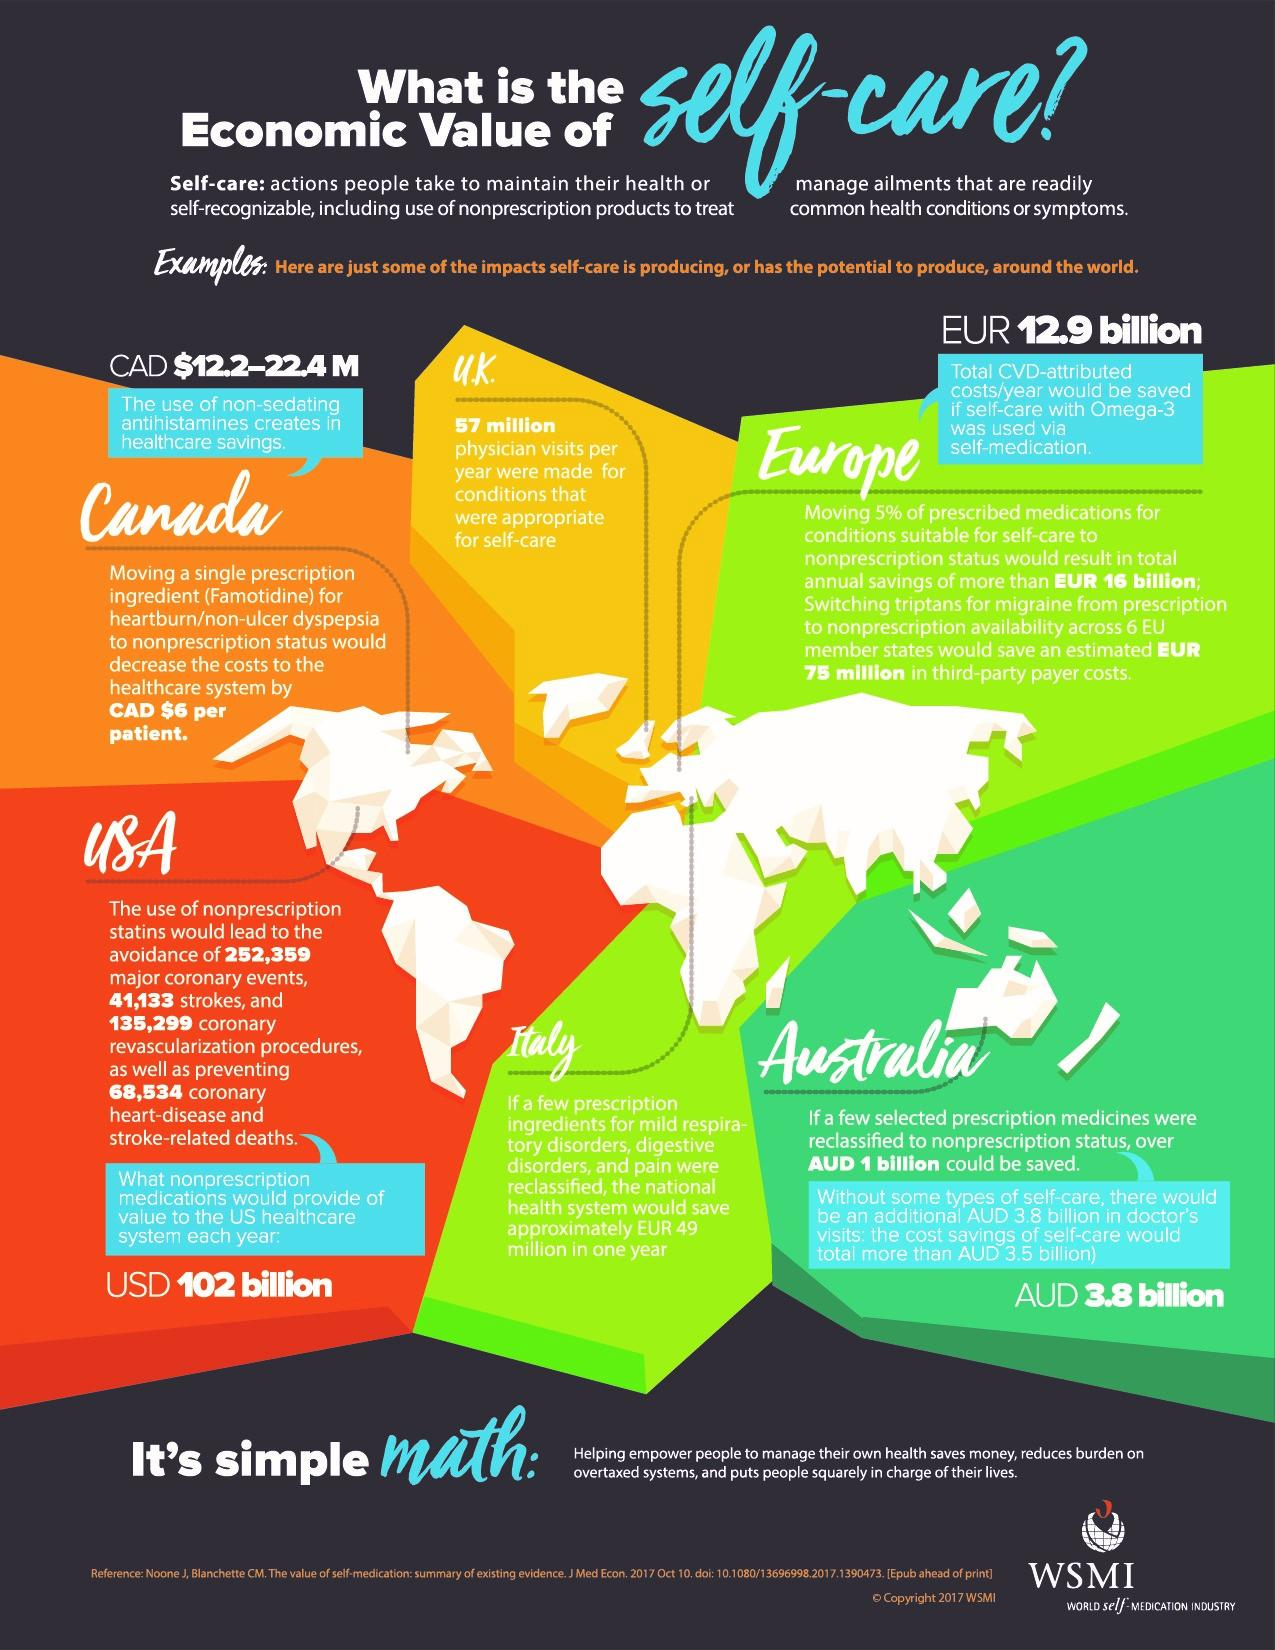Point out several critical features in this image. The estimated amount of money saved by Australia if prescription medicines were classified would be 3.8 billion. According to estimates, the number of heart-related disorders that could be avoided if non-prescription statins were introduced is approximately 497,325. There are six geographic regions mentioned on the map. 